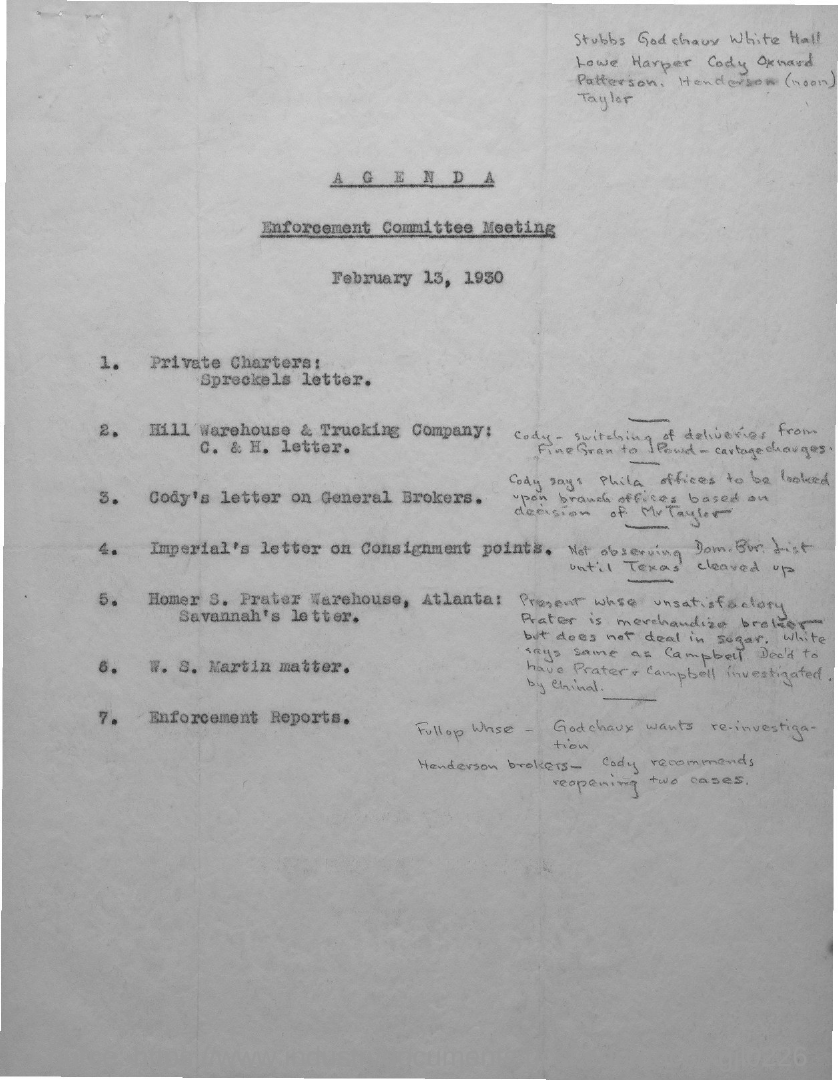When is the enforcement committee meeting held as per the agenda?
Ensure brevity in your answer.  February 13, 1930. 